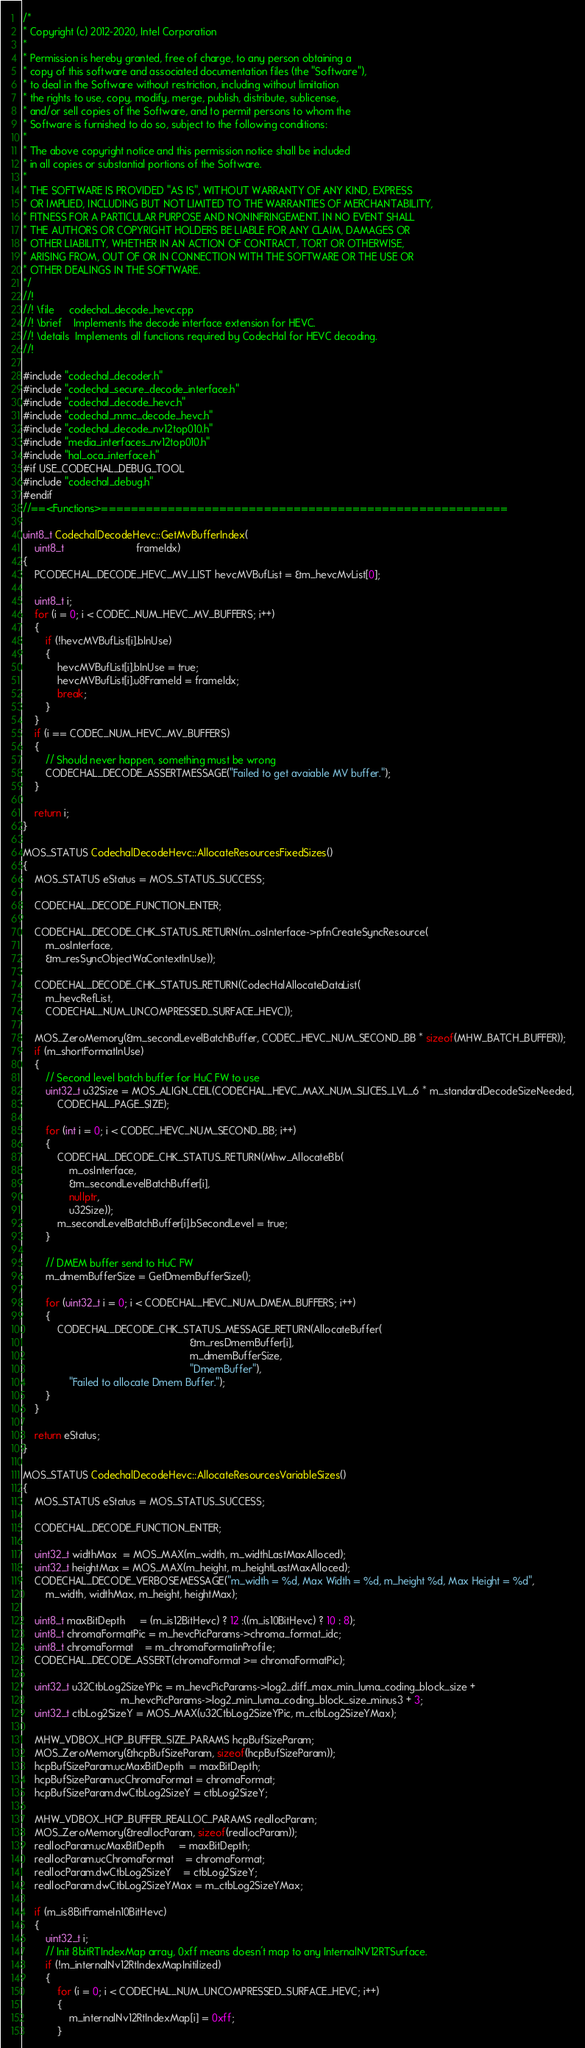Convert code to text. <code><loc_0><loc_0><loc_500><loc_500><_C++_>/*
* Copyright (c) 2012-2020, Intel Corporation
*
* Permission is hereby granted, free of charge, to any person obtaining a
* copy of this software and associated documentation files (the "Software"),
* to deal in the Software without restriction, including without limitation
* the rights to use, copy, modify, merge, publish, distribute, sublicense,
* and/or sell copies of the Software, and to permit persons to whom the
* Software is furnished to do so, subject to the following conditions:
*
* The above copyright notice and this permission notice shall be included
* in all copies or substantial portions of the Software.
*
* THE SOFTWARE IS PROVIDED "AS IS", WITHOUT WARRANTY OF ANY KIND, EXPRESS
* OR IMPLIED, INCLUDING BUT NOT LIMITED TO THE WARRANTIES OF MERCHANTABILITY,
* FITNESS FOR A PARTICULAR PURPOSE AND NONINFRINGEMENT. IN NO EVENT SHALL
* THE AUTHORS OR COPYRIGHT HOLDERS BE LIABLE FOR ANY CLAIM, DAMAGES OR
* OTHER LIABILITY, WHETHER IN AN ACTION OF CONTRACT, TORT OR OTHERWISE,
* ARISING FROM, OUT OF OR IN CONNECTION WITH THE SOFTWARE OR THE USE OR
* OTHER DEALINGS IN THE SOFTWARE.
*/
//!
//! \file     codechal_decode_hevc.cpp
//! \brief    Implements the decode interface extension for HEVC.
//! \details  Implements all functions required by CodecHal for HEVC decoding.
//!

#include "codechal_decoder.h"
#include "codechal_secure_decode_interface.h"
#include "codechal_decode_hevc.h"
#include "codechal_mmc_decode_hevc.h"
#include "codechal_decode_nv12top010.h"
#include "media_interfaces_nv12top010.h"
#include "hal_oca_interface.h"
#if USE_CODECHAL_DEBUG_TOOL
#include "codechal_debug.h"
#endif
//==<Functions>=======================================================

uint8_t CodechalDecodeHevc::GetMvBufferIndex(
    uint8_t                         frameIdx)
{
    PCODECHAL_DECODE_HEVC_MV_LIST hevcMVBufList = &m_hevcMvList[0];

    uint8_t i;
    for (i = 0; i < CODEC_NUM_HEVC_MV_BUFFERS; i++)
    {
        if (!hevcMVBufList[i].bInUse)
        {
            hevcMVBufList[i].bInUse = true;
            hevcMVBufList[i].u8FrameId = frameIdx;
            break;
        }
    }
    if (i == CODEC_NUM_HEVC_MV_BUFFERS)
    {
        // Should never happen, something must be wrong
        CODECHAL_DECODE_ASSERTMESSAGE("Failed to get avaiable MV buffer.");
    }

    return i;
}

MOS_STATUS CodechalDecodeHevc::AllocateResourcesFixedSizes()
{
    MOS_STATUS eStatus = MOS_STATUS_SUCCESS;

    CODECHAL_DECODE_FUNCTION_ENTER;

    CODECHAL_DECODE_CHK_STATUS_RETURN(m_osInterface->pfnCreateSyncResource(
        m_osInterface,
        &m_resSyncObjectWaContextInUse));

    CODECHAL_DECODE_CHK_STATUS_RETURN(CodecHalAllocateDataList(
        m_hevcRefList,
        CODECHAL_NUM_UNCOMPRESSED_SURFACE_HEVC));

    MOS_ZeroMemory(&m_secondLevelBatchBuffer, CODEC_HEVC_NUM_SECOND_BB * sizeof(MHW_BATCH_BUFFER));
    if (m_shortFormatInUse)
    {
        // Second level batch buffer for HuC FW to use
        uint32_t u32Size = MOS_ALIGN_CEIL(CODECHAL_HEVC_MAX_NUM_SLICES_LVL_6 * m_standardDecodeSizeNeeded,
            CODECHAL_PAGE_SIZE);

        for (int i = 0; i < CODEC_HEVC_NUM_SECOND_BB; i++)
        {
            CODECHAL_DECODE_CHK_STATUS_RETURN(Mhw_AllocateBb(
                m_osInterface,
                &m_secondLevelBatchBuffer[i],
                nullptr,
                u32Size));
            m_secondLevelBatchBuffer[i].bSecondLevel = true;
        }

        // DMEM buffer send to HuC FW
        m_dmemBufferSize = GetDmemBufferSize();

        for (uint32_t i = 0; i < CODECHAL_HEVC_NUM_DMEM_BUFFERS; i++)
        {
            CODECHAL_DECODE_CHK_STATUS_MESSAGE_RETURN(AllocateBuffer(
                                                          &m_resDmemBuffer[i],
                                                          m_dmemBufferSize,
                                                          "DmemBuffer"),
                "Failed to allocate Dmem Buffer.");
        }
    }

    return eStatus;
}

MOS_STATUS CodechalDecodeHevc::AllocateResourcesVariableSizes()
{
    MOS_STATUS eStatus = MOS_STATUS_SUCCESS;

    CODECHAL_DECODE_FUNCTION_ENTER;

    uint32_t widthMax  = MOS_MAX(m_width, m_widthLastMaxAlloced);
    uint32_t heightMax = MOS_MAX(m_height, m_heightLastMaxAlloced);
    CODECHAL_DECODE_VERBOSEMESSAGE("m_width = %d, Max Width = %d, m_height %d, Max Height = %d",
        m_width, widthMax, m_height, heightMax);

    uint8_t maxBitDepth     = (m_is12BitHevc) ? 12 :((m_is10BitHevc) ? 10 : 8);
    uint8_t chromaFormatPic = m_hevcPicParams->chroma_format_idc;
    uint8_t chromaFormat    = m_chromaFormatinProfile;
    CODECHAL_DECODE_ASSERT(chromaFormat >= chromaFormatPic);

    uint32_t u32CtbLog2SizeYPic = m_hevcPicParams->log2_diff_max_min_luma_coding_block_size +
                                  m_hevcPicParams->log2_min_luma_coding_block_size_minus3 + 3;
    uint32_t ctbLog2SizeY = MOS_MAX(u32CtbLog2SizeYPic, m_ctbLog2SizeYMax);

    MHW_VDBOX_HCP_BUFFER_SIZE_PARAMS hcpBufSizeParam;
    MOS_ZeroMemory(&hcpBufSizeParam, sizeof(hcpBufSizeParam));
    hcpBufSizeParam.ucMaxBitDepth  = maxBitDepth;
    hcpBufSizeParam.ucChromaFormat = chromaFormat;
    hcpBufSizeParam.dwCtbLog2SizeY = ctbLog2SizeY;

    MHW_VDBOX_HCP_BUFFER_REALLOC_PARAMS reallocParam;
    MOS_ZeroMemory(&reallocParam, sizeof(reallocParam));
    reallocParam.ucMaxBitDepth     = maxBitDepth;
    reallocParam.ucChromaFormat    = chromaFormat;
    reallocParam.dwCtbLog2SizeY    = ctbLog2SizeY;
    reallocParam.dwCtbLog2SizeYMax = m_ctbLog2SizeYMax;

    if (m_is8BitFrameIn10BitHevc)
    {
        uint32_t i;
        // Init 8bitRTIndexMap array, 0xff means doesn't map to any InternalNV12RTSurface.
        if (!m_internalNv12RtIndexMapInitilized)
        {
            for (i = 0; i < CODECHAL_NUM_UNCOMPRESSED_SURFACE_HEVC; i++)
            {
                m_internalNv12RtIndexMap[i] = 0xff;
            }
</code> 